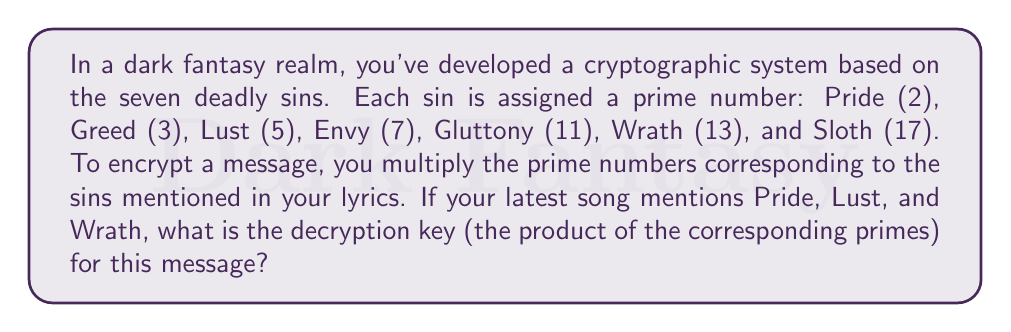Provide a solution to this math problem. To solve this problem, we need to follow these steps:

1. Identify the prime numbers associated with the mentioned sins:
   Pride: 2
   Lust: 5
   Wrath: 13

2. Multiply these prime numbers to get the decryption key:

   $$ \text{Decryption Key} = 2 \times 5 \times 13 $$

3. Perform the multiplication:

   $$ \begin{aligned}
   \text{Decryption Key} &= 2 \times 5 \times 13 \\
   &= 10 \times 13 \\
   &= 130
   \end{aligned} $$

Therefore, the decryption key for a message encrypted using Pride, Lust, and Wrath is 130.
Answer: 130 